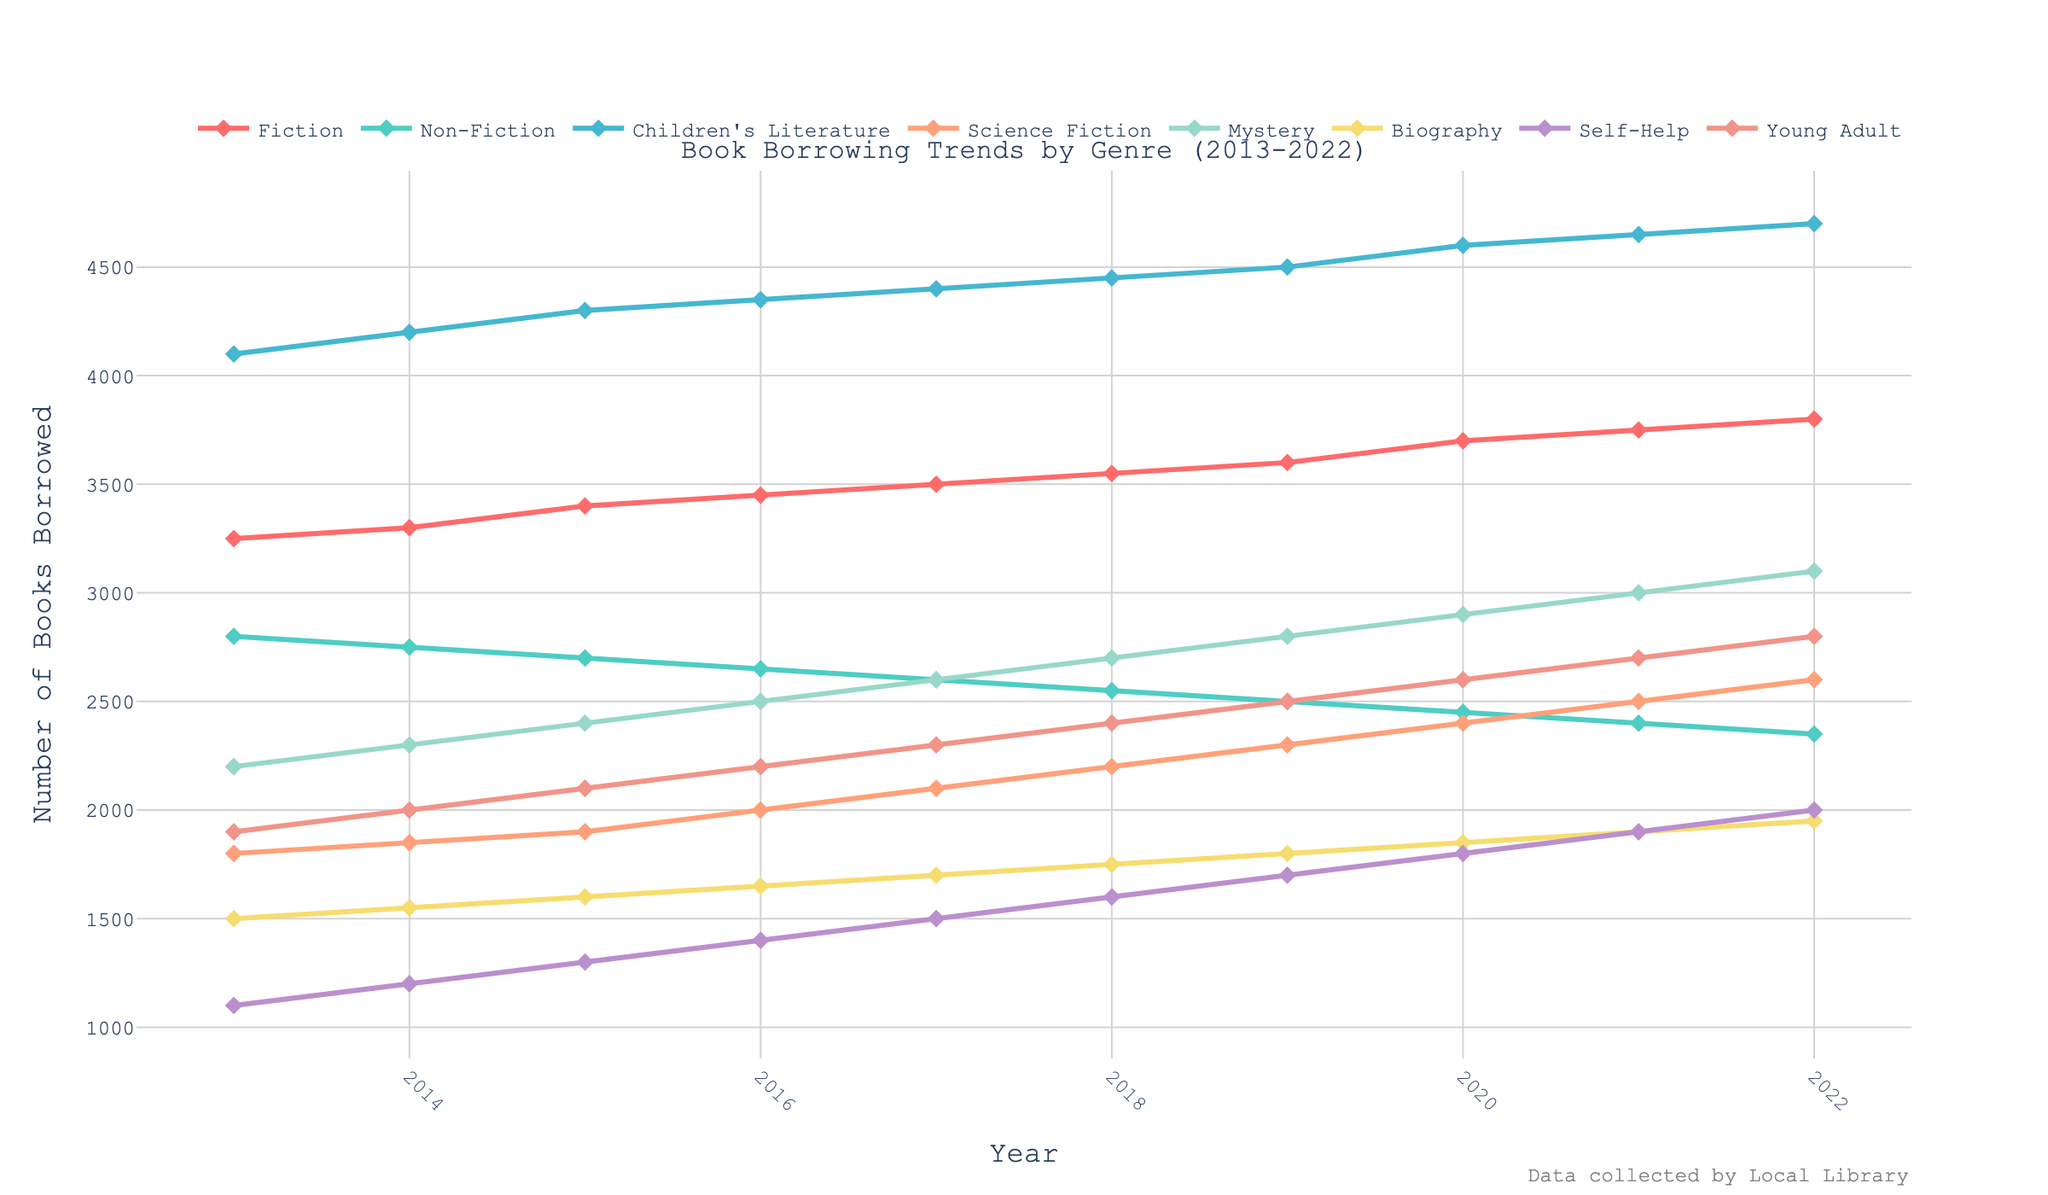Which genre has the highest borrowing rate in 2022? Looking at the trend lines for each genre, find the genre with the highest y-value in the year 2022. The highest value is 4700, which corresponds to Children's Literature.
Answer: Children's Literature Which genre shows a consistent increase in borrowing rates from 2013 to 2022? Identify the trend lines that have a steady upward slope from 2013 to 2022 without any dips. Fiction, Non-Fiction, Children's Literature, Science Fiction, Mystery, Biography, Self-Help, and Young Adult show consistent increases.
Answer: All genres By how much did the borrowing rate of Mystery books increase from 2013 to 2022? Check the y-values for Mystery in 2013 and 2022. The values are 2200 and 3100, respectively. Calculate the difference: 3100 - 2200 = 900.
Answer: 900 What is the average borrowing rate for Science Fiction books over the years 2013 to 2022? Sum the borrowing rates for Science Fiction from 2013 to 2022 and divide by the number of years, which is 10. Sum: 1800 + 1850 + 1900 + 2000 + 2100 + 2200 + 2300 + 2400 + 2500 + 2600 = 21650. Average: 21650 / 10 = 2165.
Answer: 2165 Which year saw the highest borrowing rate for Biography books? Observe the trend line for Biography and find the year where the y-value peaks. The highest value is 1950, occurring in 2022.
Answer: 2022 What is the difference between the borrowing rates of Fiction and Non-Fiction books in 2020? In 2020, the borrowing rates are 3700 for Fiction and 2450 for Non-Fiction. Calculate the difference: 3700 - 2450 = 1250.
Answer: 1250 Which genre had the least variation in borrowing rates from 2013 to 2022? Identify the trend line with the smallest range between its highest and lowest points. Sum all differences: Fiction (3800-3250=550), Non-Fiction (2800-2350=450), Children’s Literature (4700-4100=600), Science Fiction (2600-1800=800), Mystery (3100-2200=900), Biography (1950-1500=450), Self-Help (2000-1100=900), Young Adult (2800-1900=900). The least variation is in Biography, Non-Fiction, both with a range of 450.
Answer: Biography, Non-Fiction 